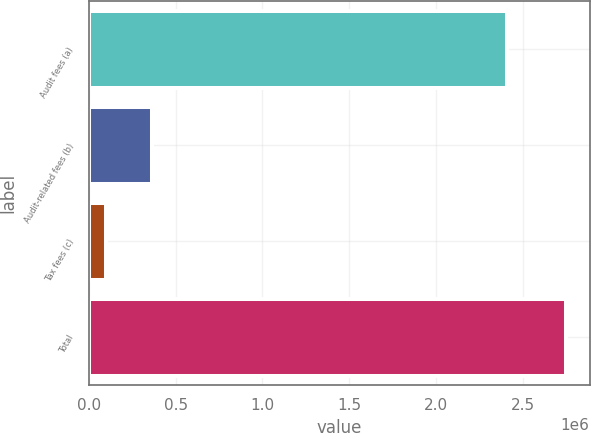Convert chart. <chart><loc_0><loc_0><loc_500><loc_500><bar_chart><fcel>Audit fees (a)<fcel>Audit-related fees (b)<fcel>Tax fees (c)<fcel>Total<nl><fcel>2.41e+06<fcel>365700<fcel>101000<fcel>2.748e+06<nl></chart> 